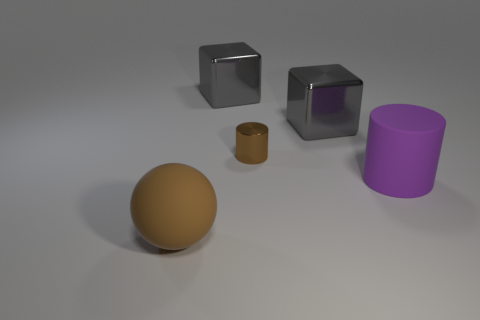Subtract all gray blocks. How many were subtracted if there are1gray blocks left? 1 Add 1 large purple blocks. How many objects exist? 6 Subtract all purple cylinders. How many cylinders are left? 1 Subtract 1 blocks. How many blocks are left? 1 Add 1 big objects. How many big objects are left? 5 Add 2 purple matte cylinders. How many purple matte cylinders exist? 3 Subtract 0 yellow cylinders. How many objects are left? 5 Subtract all cubes. How many objects are left? 3 Subtract all red cylinders. Subtract all blue blocks. How many cylinders are left? 2 Subtract all purple matte things. Subtract all brown matte cubes. How many objects are left? 4 